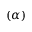Convert formula to latex. <formula><loc_0><loc_0><loc_500><loc_500>( \alpha )</formula> 